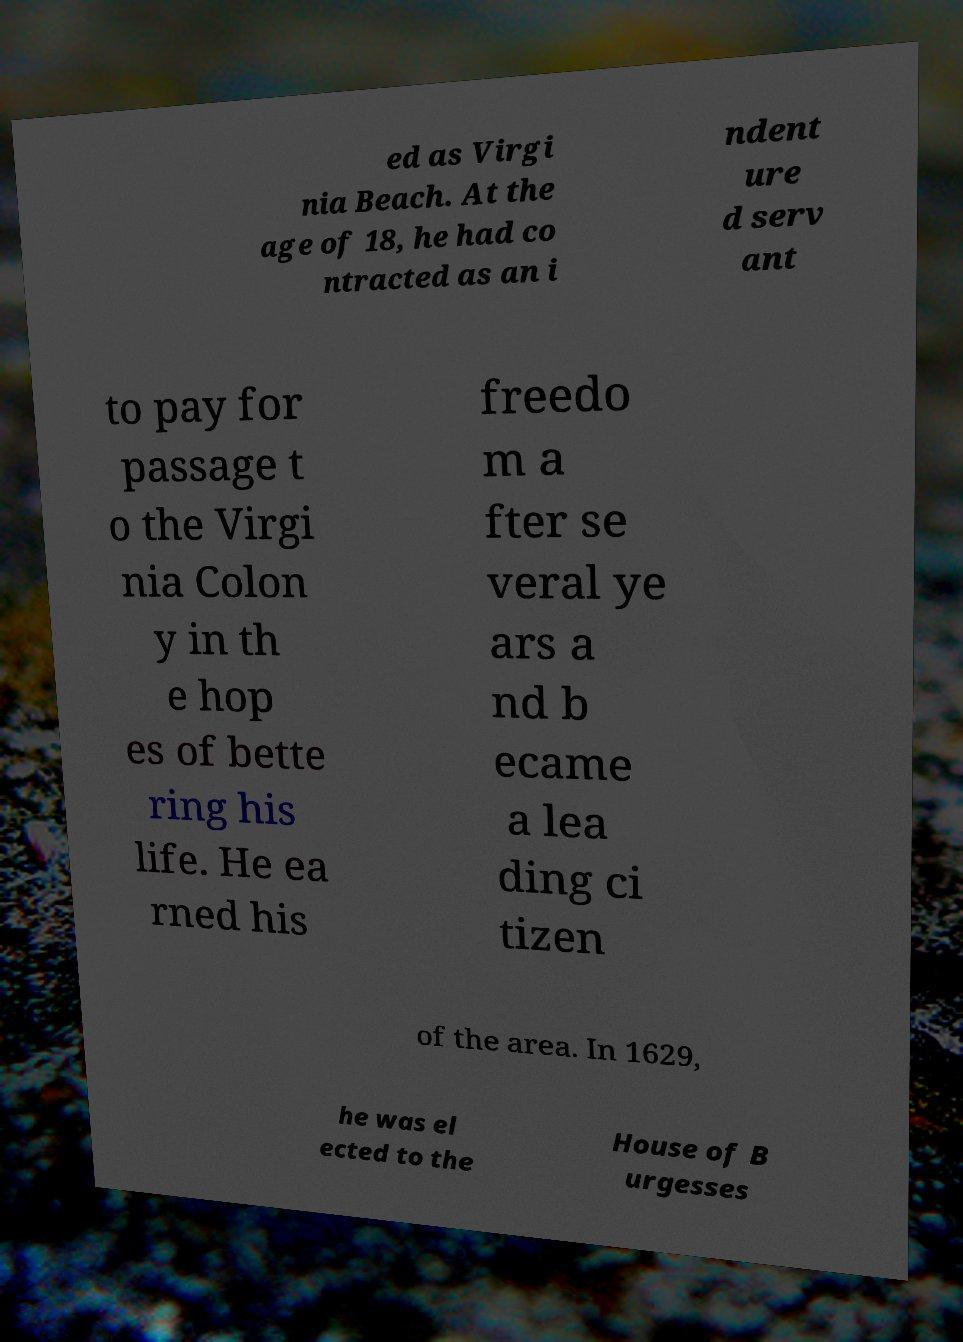I need the written content from this picture converted into text. Can you do that? ed as Virgi nia Beach. At the age of 18, he had co ntracted as an i ndent ure d serv ant to pay for passage t o the Virgi nia Colon y in th e hop es of bette ring his life. He ea rned his freedo m a fter se veral ye ars a nd b ecame a lea ding ci tizen of the area. In 1629, he was el ected to the House of B urgesses 